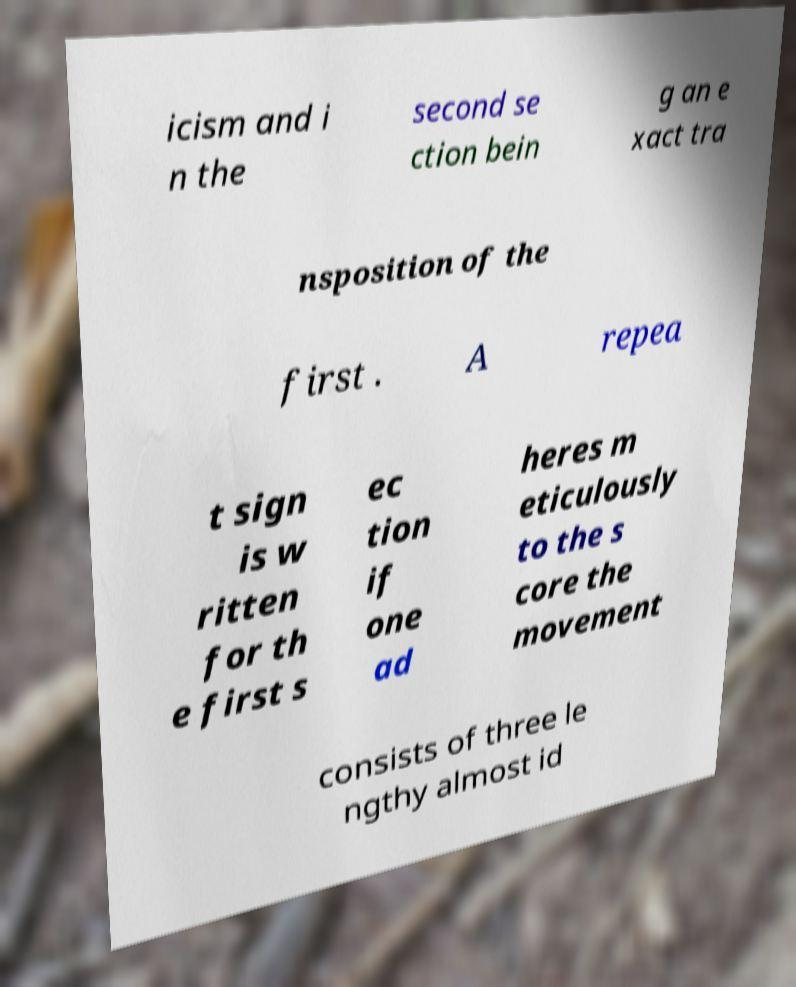Can you read and provide the text displayed in the image?This photo seems to have some interesting text. Can you extract and type it out for me? icism and i n the second se ction bein g an e xact tra nsposition of the first . A repea t sign is w ritten for th e first s ec tion if one ad heres m eticulously to the s core the movement consists of three le ngthy almost id 